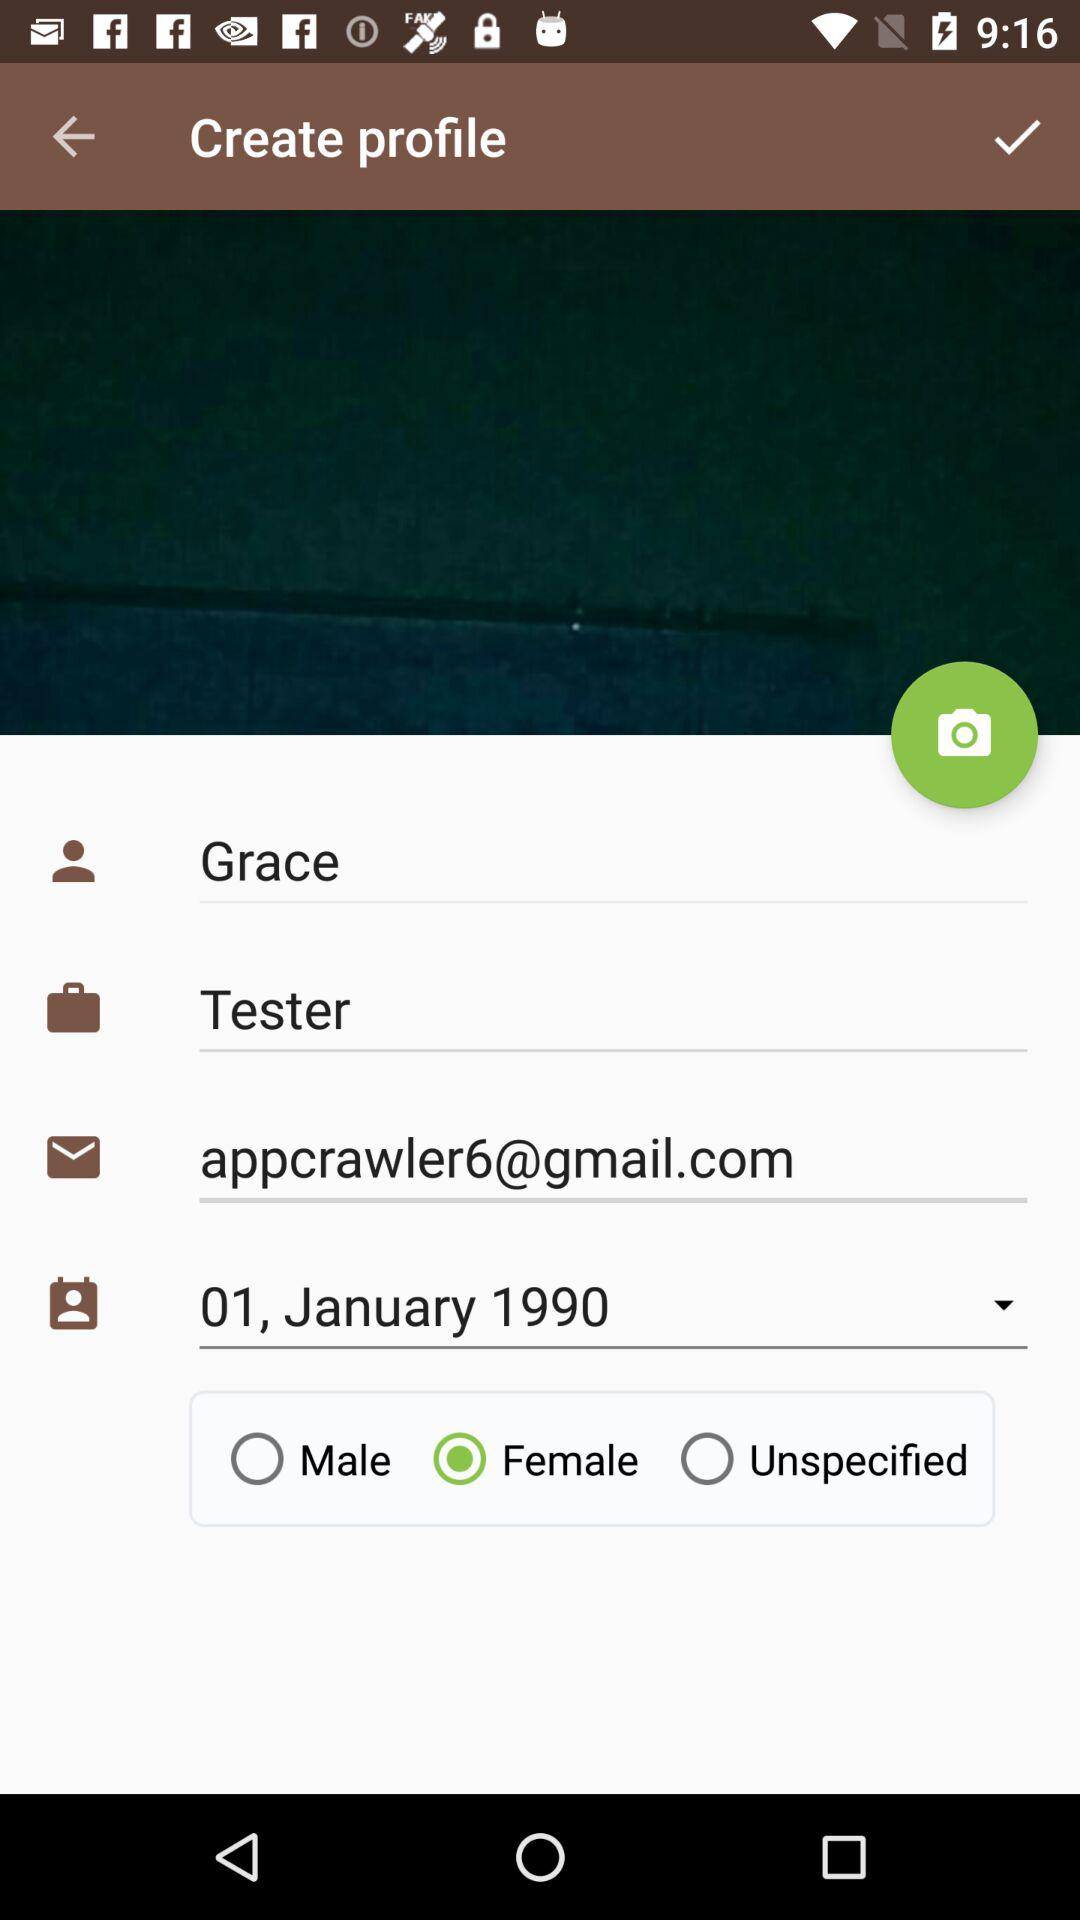What is the designation of the user? The designation of the user is "Tester". 